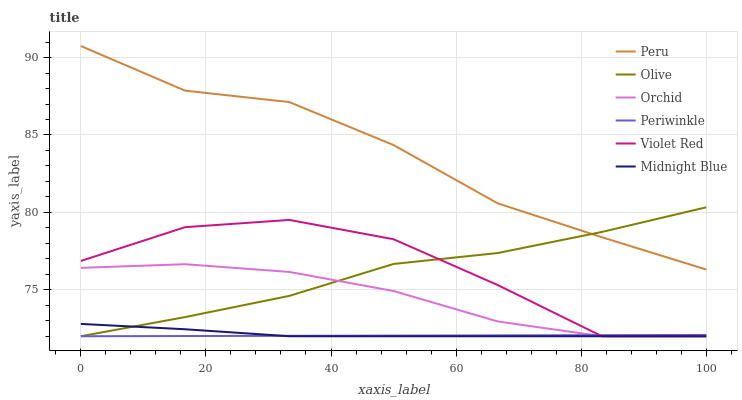Does Periwinkle have the minimum area under the curve?
Answer yes or no. Yes. Does Peru have the maximum area under the curve?
Answer yes or no. Yes. Does Midnight Blue have the minimum area under the curve?
Answer yes or no. No. Does Midnight Blue have the maximum area under the curve?
Answer yes or no. No. Is Periwinkle the smoothest?
Answer yes or no. Yes. Is Violet Red the roughest?
Answer yes or no. Yes. Is Midnight Blue the smoothest?
Answer yes or no. No. Is Midnight Blue the roughest?
Answer yes or no. No. Does Peru have the lowest value?
Answer yes or no. No. Does Peru have the highest value?
Answer yes or no. Yes. Does Midnight Blue have the highest value?
Answer yes or no. No. Is Midnight Blue less than Peru?
Answer yes or no. Yes. Is Peru greater than Violet Red?
Answer yes or no. Yes. Does Midnight Blue intersect Olive?
Answer yes or no. Yes. Is Midnight Blue less than Olive?
Answer yes or no. No. Is Midnight Blue greater than Olive?
Answer yes or no. No. Does Midnight Blue intersect Peru?
Answer yes or no. No. 